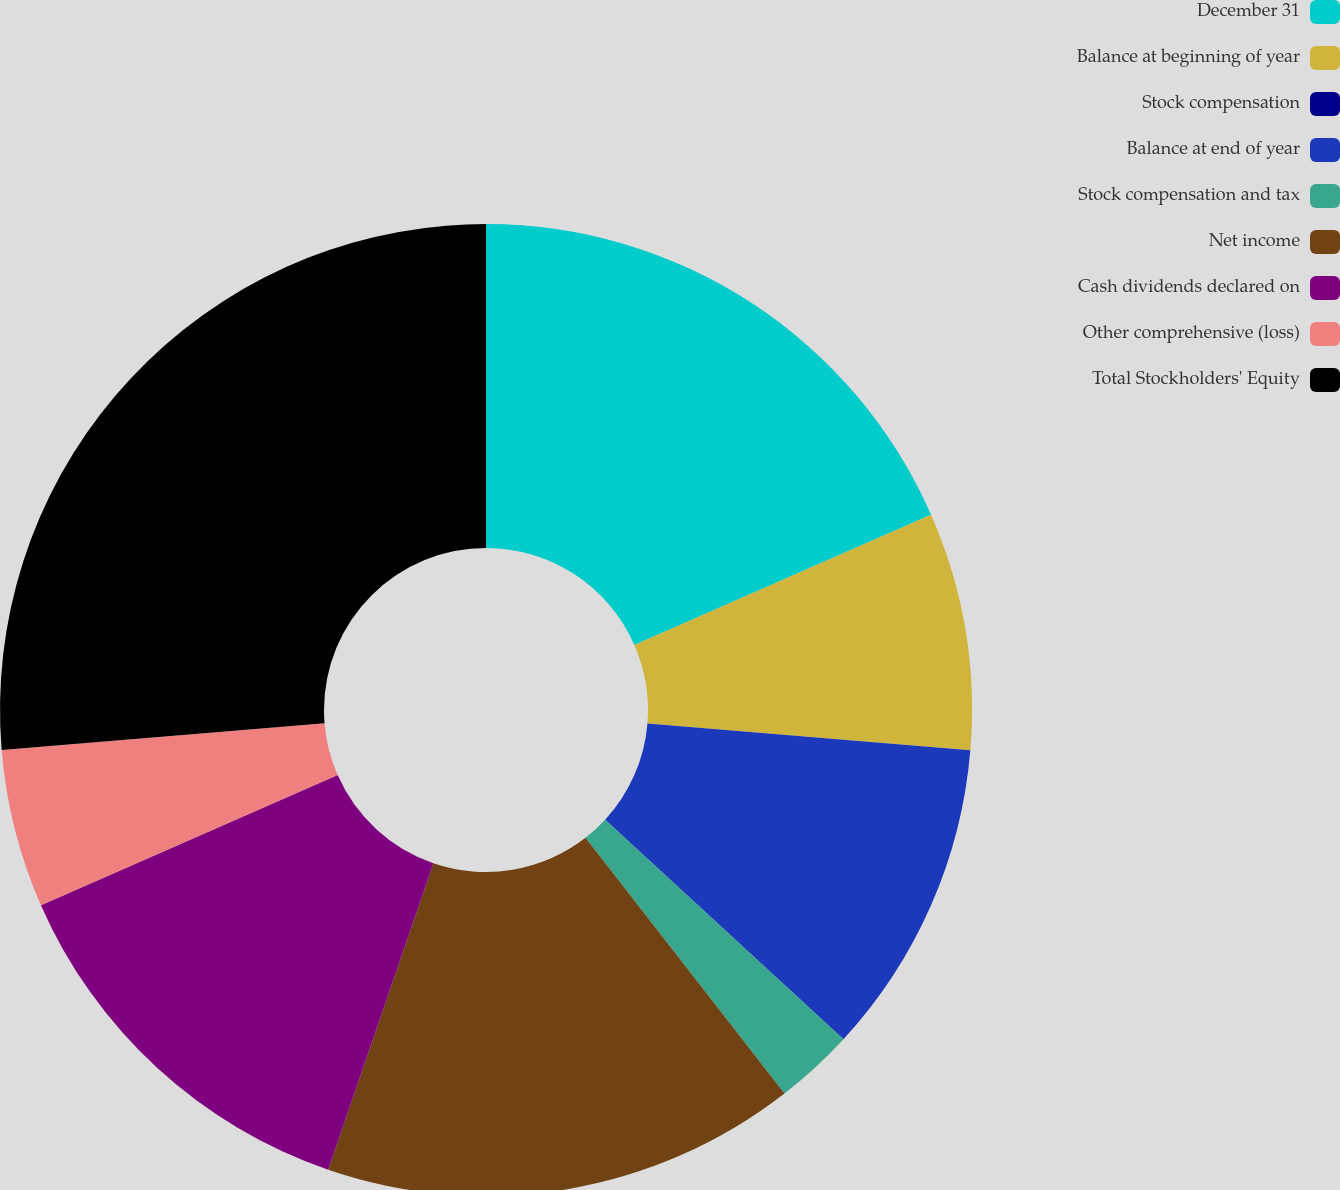Convert chart. <chart><loc_0><loc_0><loc_500><loc_500><pie_chart><fcel>December 31<fcel>Balance at beginning of year<fcel>Stock compensation<fcel>Balance at end of year<fcel>Stock compensation and tax<fcel>Net income<fcel>Cash dividends declared on<fcel>Other comprehensive (loss)<fcel>Total Stockholders' Equity<nl><fcel>18.42%<fcel>7.9%<fcel>0.0%<fcel>10.53%<fcel>2.63%<fcel>15.79%<fcel>13.16%<fcel>5.27%<fcel>26.31%<nl></chart> 